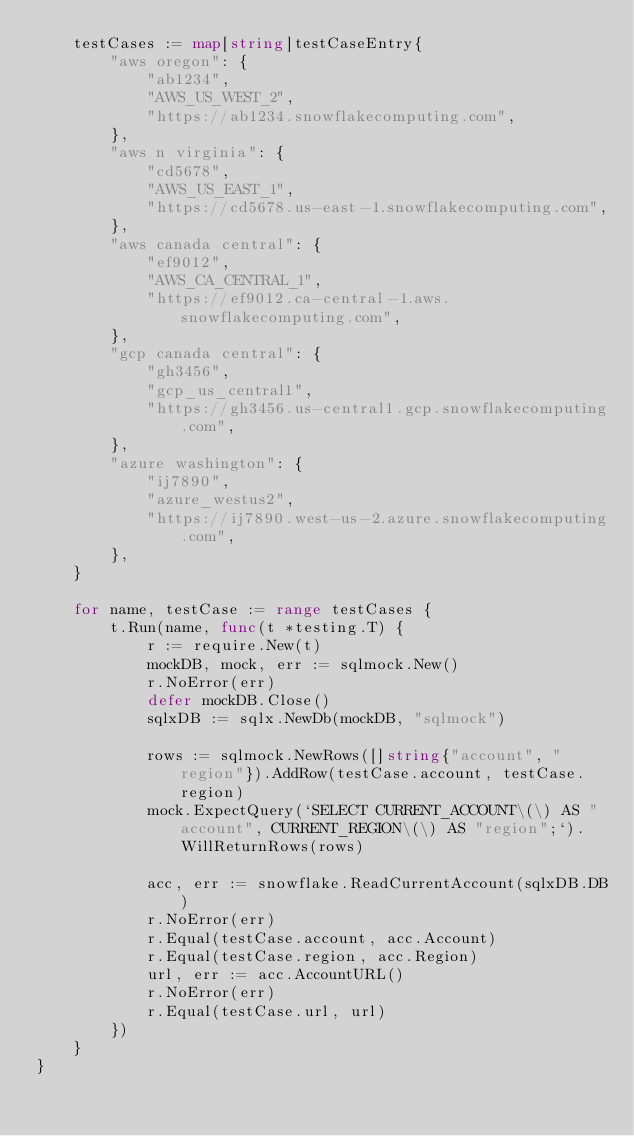Convert code to text. <code><loc_0><loc_0><loc_500><loc_500><_Go_>	testCases := map[string]testCaseEntry{
		"aws oregon": {
			"ab1234",
			"AWS_US_WEST_2",
			"https://ab1234.snowflakecomputing.com",
		},
		"aws n virginia": {
			"cd5678",
			"AWS_US_EAST_1",
			"https://cd5678.us-east-1.snowflakecomputing.com",
		},
		"aws canada central": {
			"ef9012",
			"AWS_CA_CENTRAL_1",
			"https://ef9012.ca-central-1.aws.snowflakecomputing.com",
		},
		"gcp canada central": {
			"gh3456",
			"gcp_us_central1",
			"https://gh3456.us-central1.gcp.snowflakecomputing.com",
		},
		"azure washington": {
			"ij7890",
			"azure_westus2",
			"https://ij7890.west-us-2.azure.snowflakecomputing.com",
		},
	}

	for name, testCase := range testCases {
		t.Run(name, func(t *testing.T) {
			r := require.New(t)
			mockDB, mock, err := sqlmock.New()
			r.NoError(err)
			defer mockDB.Close()
			sqlxDB := sqlx.NewDb(mockDB, "sqlmock")

			rows := sqlmock.NewRows([]string{"account", "region"}).AddRow(testCase.account, testCase.region)
			mock.ExpectQuery(`SELECT CURRENT_ACCOUNT\(\) AS "account", CURRENT_REGION\(\) AS "region";`).WillReturnRows(rows)

			acc, err := snowflake.ReadCurrentAccount(sqlxDB.DB)
			r.NoError(err)
			r.Equal(testCase.account, acc.Account)
			r.Equal(testCase.region, acc.Region)
			url, err := acc.AccountURL()
			r.NoError(err)
			r.Equal(testCase.url, url)
		})
	}
}
</code> 